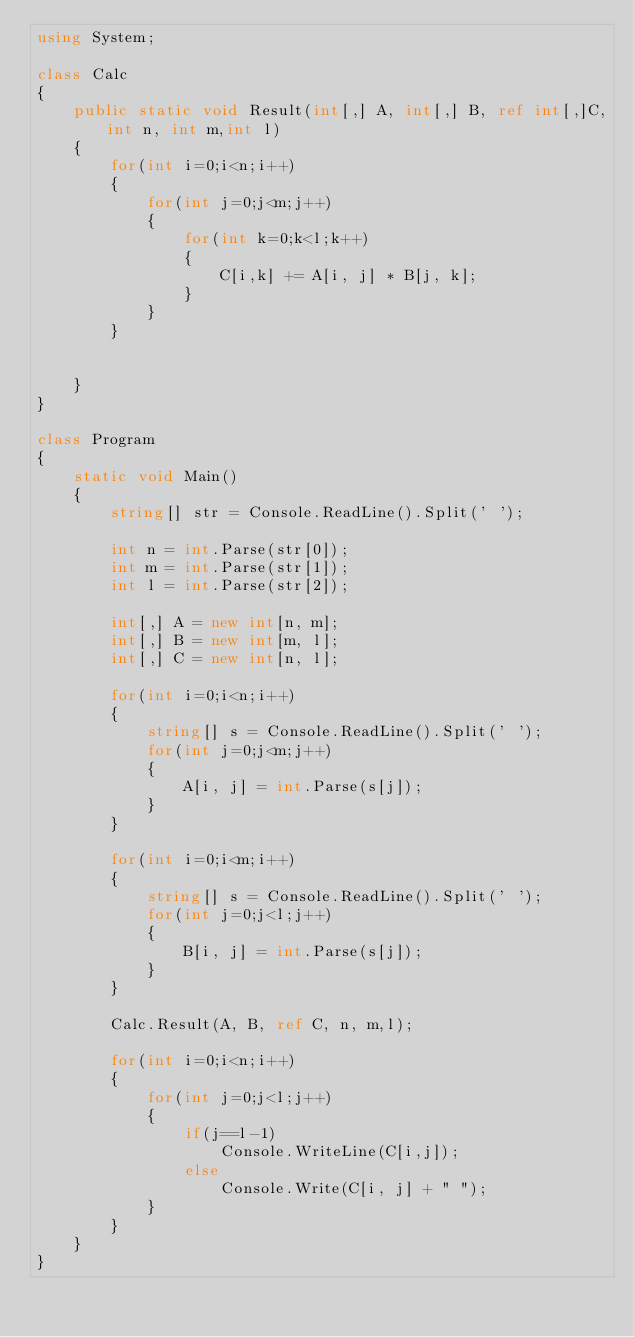<code> <loc_0><loc_0><loc_500><loc_500><_C#_>using System;

class Calc
{
    public static void Result(int[,] A, int[,] B, ref int[,]C,int n, int m,int l)
    {
        for(int i=0;i<n;i++)
        {
            for(int j=0;j<m;j++)
            {
                for(int k=0;k<l;k++)
                {
                    C[i,k] += A[i, j] * B[j, k];
                }
            }
        }


    }
}

class Program
{
    static void Main()
    {
        string[] str = Console.ReadLine().Split(' ');

        int n = int.Parse(str[0]);
        int m = int.Parse(str[1]);
        int l = int.Parse(str[2]);

        int[,] A = new int[n, m];
        int[,] B = new int[m, l];
        int[,] C = new int[n, l];

        for(int i=0;i<n;i++)
        {
            string[] s = Console.ReadLine().Split(' ');
            for(int j=0;j<m;j++)
            {
                A[i, j] = int.Parse(s[j]);
            }
        }

        for(int i=0;i<m;i++)
        {
            string[] s = Console.ReadLine().Split(' ');
            for(int j=0;j<l;j++)
            {
                B[i, j] = int.Parse(s[j]);
            }
        }

        Calc.Result(A, B, ref C, n, m,l);

        for(int i=0;i<n;i++)
        {
            for(int j=0;j<l;j++)
            {
                if(j==l-1)
                    Console.WriteLine(C[i,j]);
                else
                    Console.Write(C[i, j] + " ");
            }
        }
    }
}</code> 